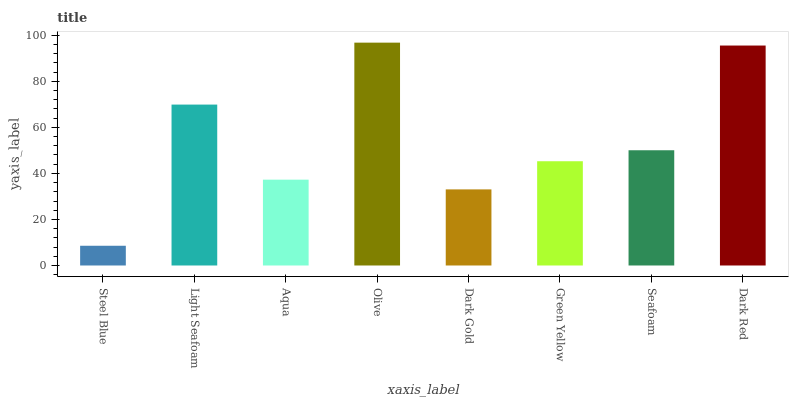Is Steel Blue the minimum?
Answer yes or no. Yes. Is Olive the maximum?
Answer yes or no. Yes. Is Light Seafoam the minimum?
Answer yes or no. No. Is Light Seafoam the maximum?
Answer yes or no. No. Is Light Seafoam greater than Steel Blue?
Answer yes or no. Yes. Is Steel Blue less than Light Seafoam?
Answer yes or no. Yes. Is Steel Blue greater than Light Seafoam?
Answer yes or no. No. Is Light Seafoam less than Steel Blue?
Answer yes or no. No. Is Seafoam the high median?
Answer yes or no. Yes. Is Green Yellow the low median?
Answer yes or no. Yes. Is Aqua the high median?
Answer yes or no. No. Is Light Seafoam the low median?
Answer yes or no. No. 